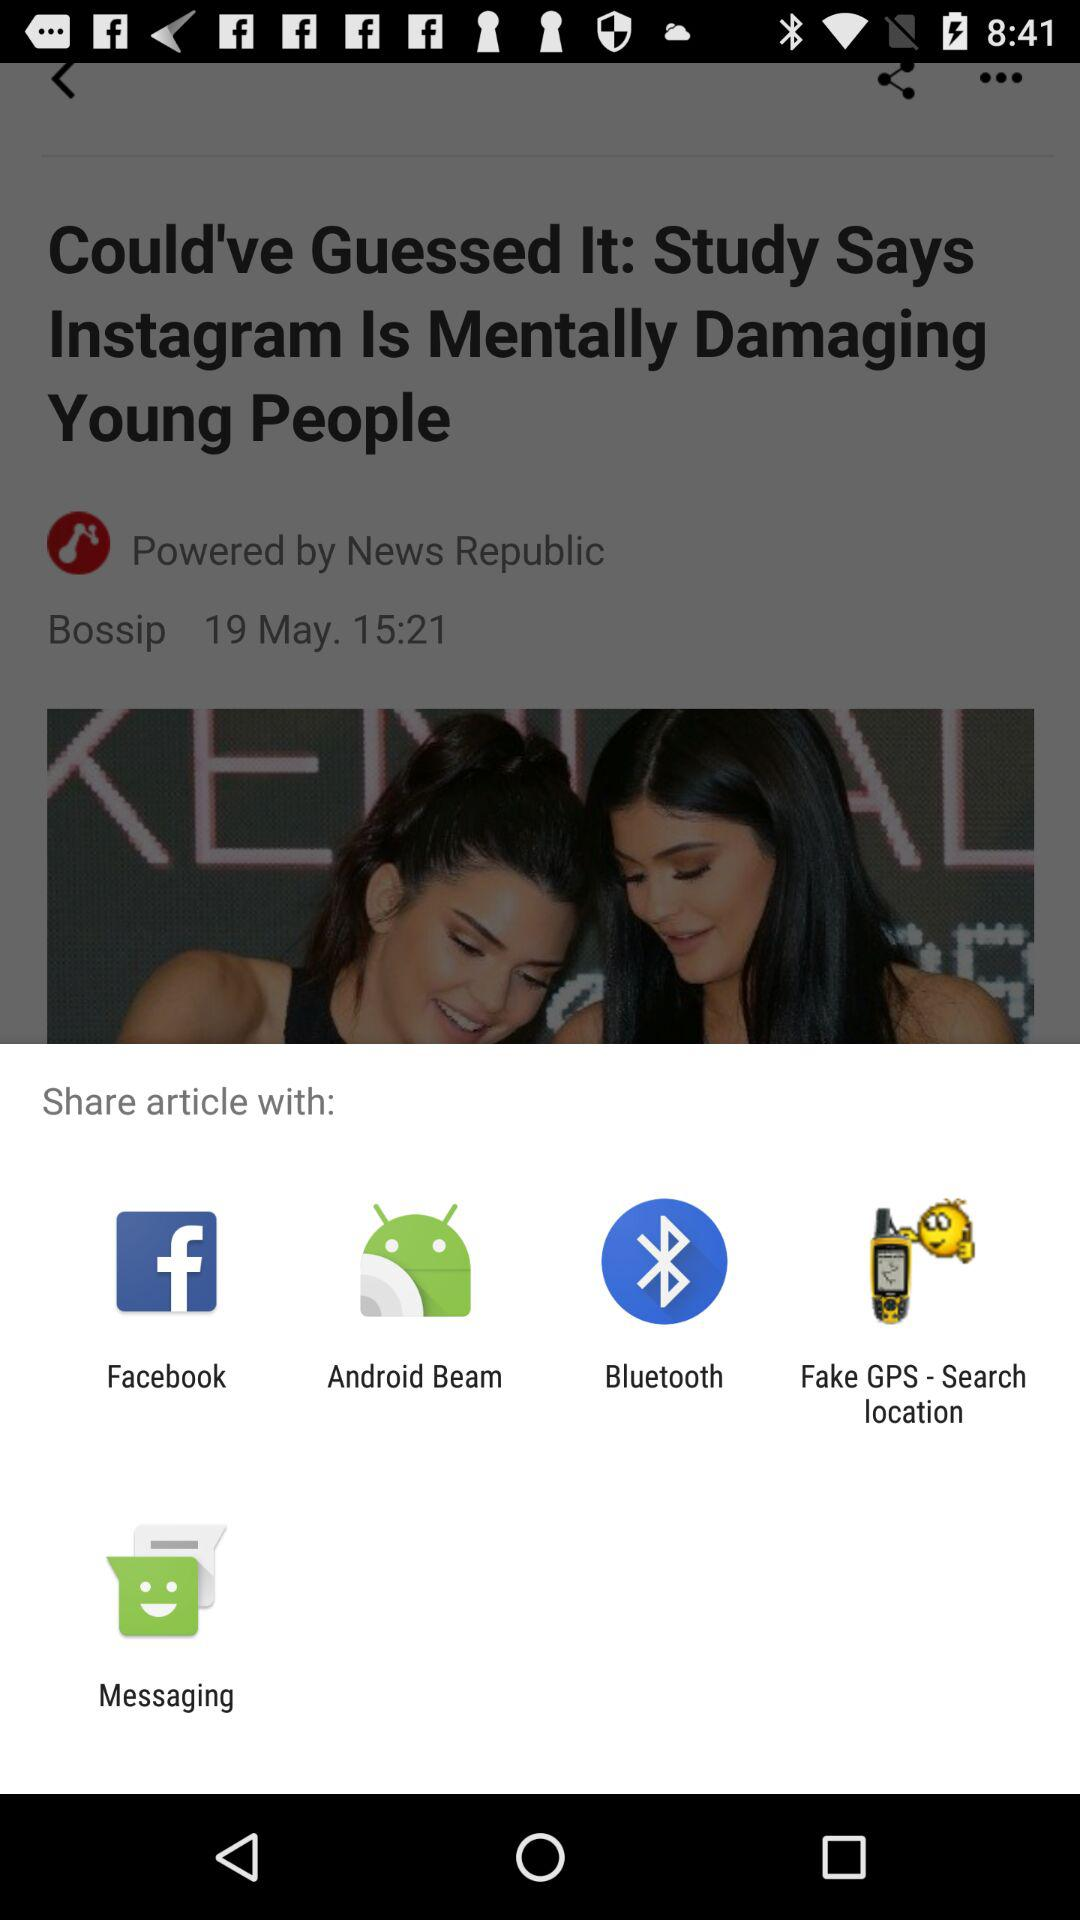When was the article posted? The article was posted on May 19 at 15:21. 